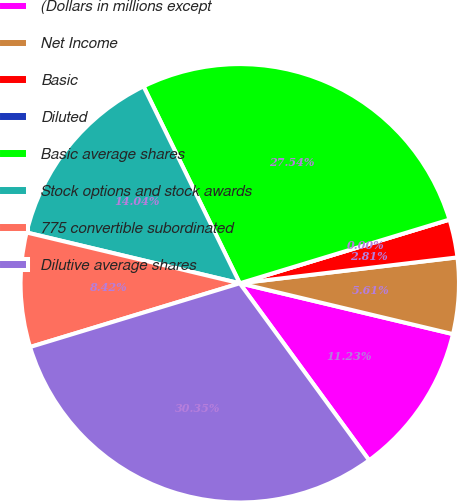Convert chart to OTSL. <chart><loc_0><loc_0><loc_500><loc_500><pie_chart><fcel>(Dollars in millions except<fcel>Net Income<fcel>Basic<fcel>Diluted<fcel>Basic average shares<fcel>Stock options and stock awards<fcel>775 convertible subordinated<fcel>Dilutive average shares<nl><fcel>11.23%<fcel>5.61%<fcel>2.81%<fcel>0.0%<fcel>27.54%<fcel>14.04%<fcel>8.42%<fcel>30.35%<nl></chart> 